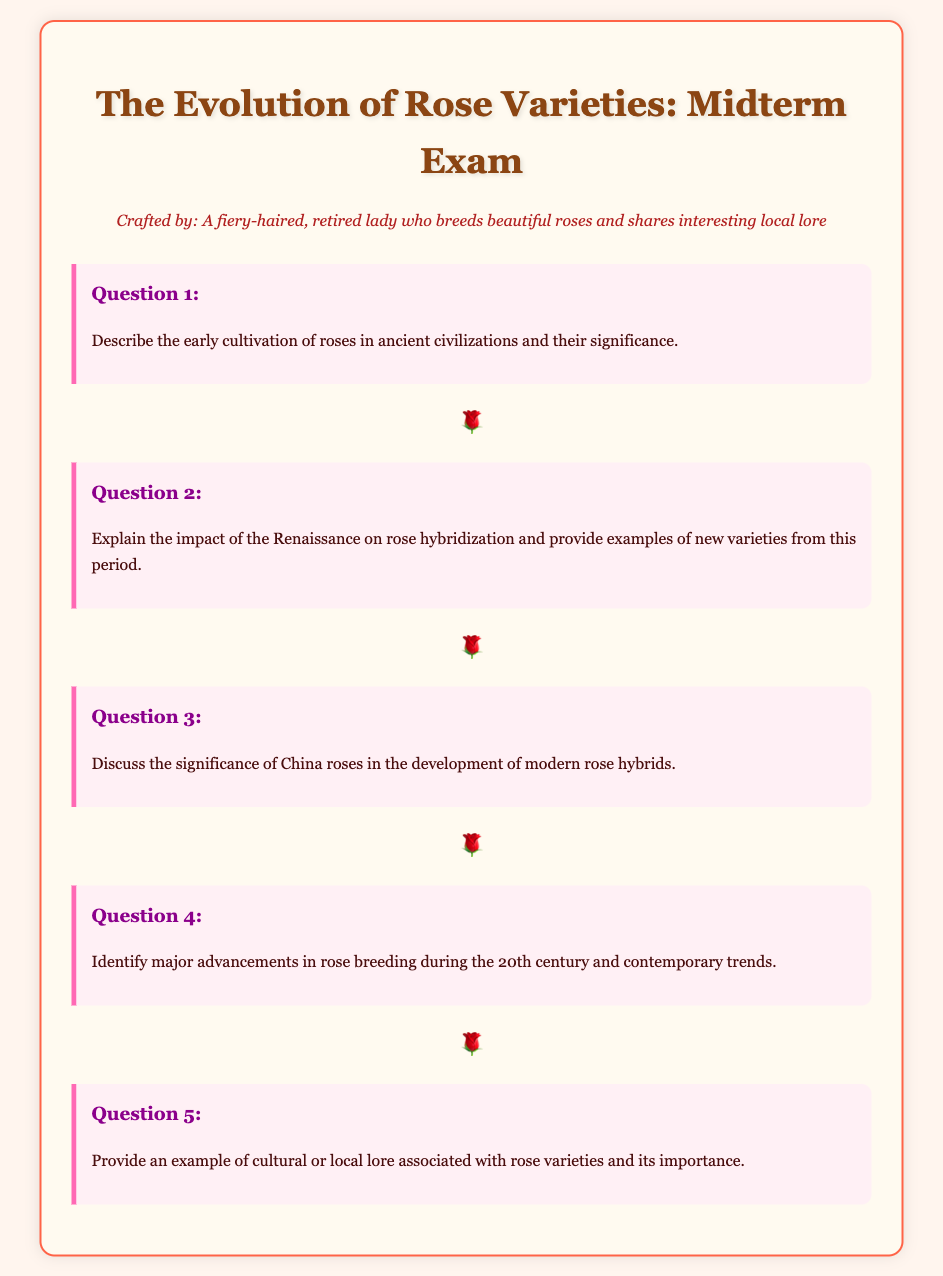What is the title of the midterm exam? The title of the midterm exam is stated at the top of the document.
Answer: The Evolution of Rose Varieties: Midterm Exam Who crafted the midterm exam? The document mentions the creator of the midterm exam in the persona section.
Answer: A fiery-haired, retired lady who breeds beautiful roses and shares interesting local lore What is the main topic of Question 1? Question 1 asks about early cultivation of roses in ancient civilizations and their significance.
Answer: Early cultivation of roses in ancient civilizations What is highlighted by the rose-divider? The rose-divider is a decorative element used to separate different questions in the document.
Answer: 🌹 What is the focus of Question 4? Question 4 identifies advancements in rose breeding during a specific century and contemporary trends.
Answer: Major advancements in rose breeding during the 20th century and contemporary trends 